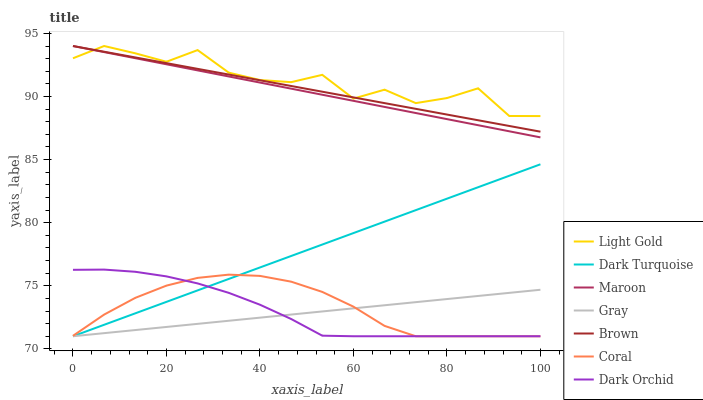Does Dark Turquoise have the minimum area under the curve?
Answer yes or no. No. Does Dark Turquoise have the maximum area under the curve?
Answer yes or no. No. Is Gray the smoothest?
Answer yes or no. No. Is Gray the roughest?
Answer yes or no. No. Does Maroon have the lowest value?
Answer yes or no. No. Does Dark Turquoise have the highest value?
Answer yes or no. No. Is Gray less than Light Gold?
Answer yes or no. Yes. Is Light Gold greater than Dark Turquoise?
Answer yes or no. Yes. Does Gray intersect Light Gold?
Answer yes or no. No. 